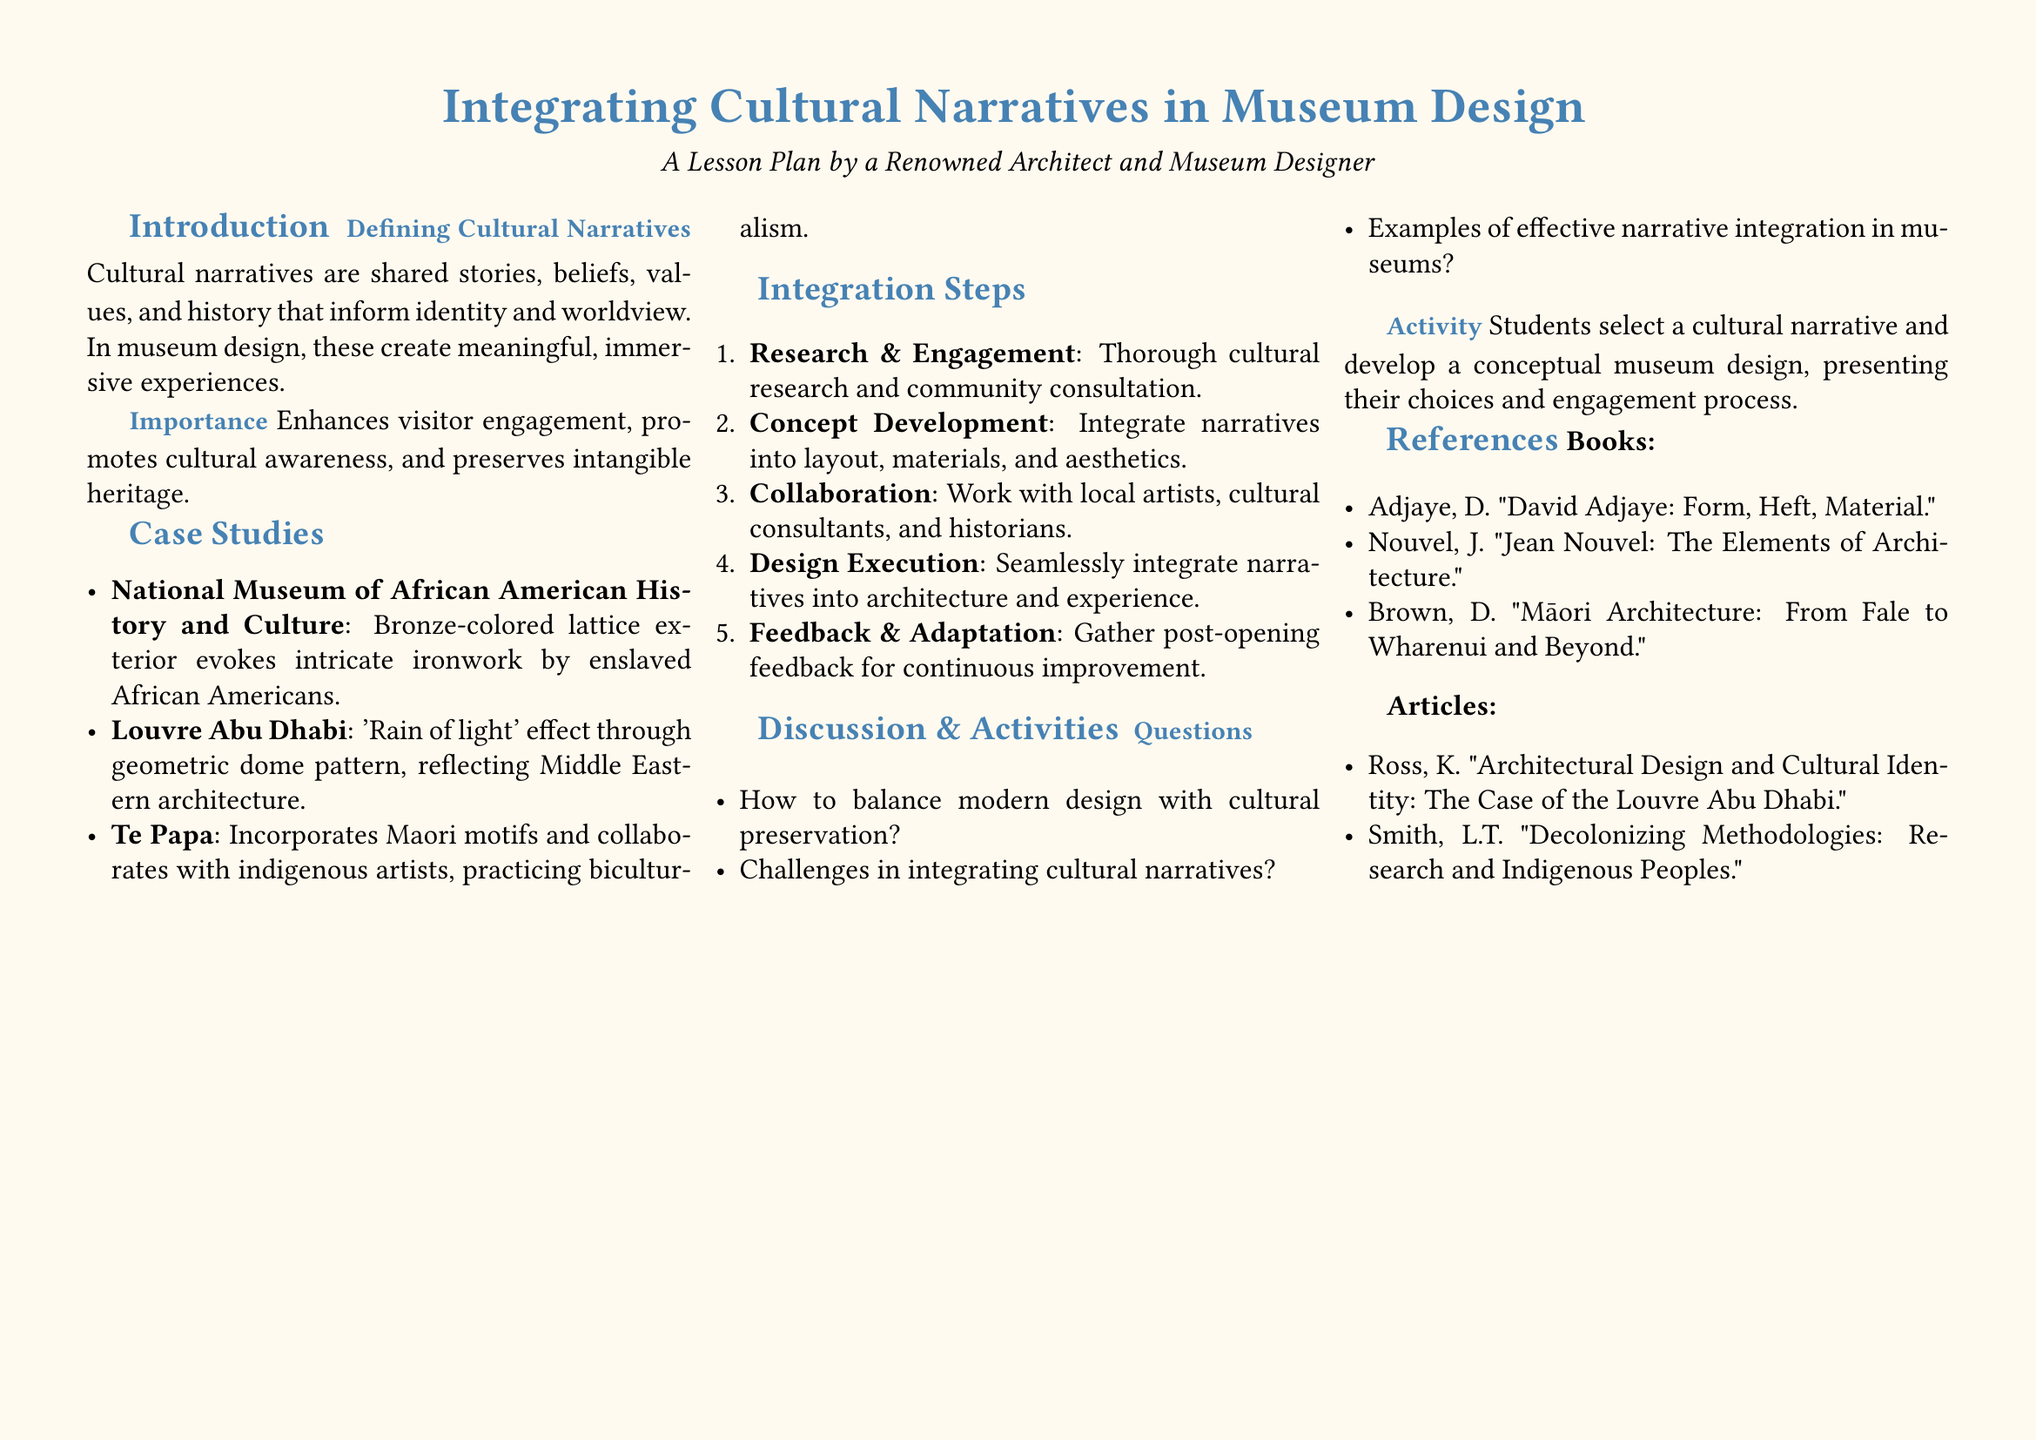What are cultural narratives? Cultural narratives are shared stories, beliefs, values, and history that inform identity and worldview.
Answer: Shared stories What is the first step in integrating cultural narratives? The first step involves thorough cultural research and community consultation.
Answer: Research & Engagement Which museum incorporates Maori motifs? The museum that incorporates Maori motifs is Te Papa.
Answer: Te Papa What effect is created by the Louvre Abu Dhabi's dome? The effect created by the Louvre Abu Dhabi's dome is 'Rain of light'.
Answer: 'Rain of light' What type of activity do students engage in? Students select a cultural narrative and develop a conceptual museum design.
Answer: Conceptual museum design What is the significance of integrating cultural narratives in museum design? Integrating cultural narratives enhances visitor engagement, promotes cultural awareness, and preserves intangible heritage.
Answer: Enhances visitor engagement What book is authored by D. Adjaye? The book authored by D. Adjaye is "David Adjaye: Form, Heft, Material."
Answer: David Adjaye: Form, Heft, Material What challenge is mentioned in the discussion section? One of the challenges mentioned is the balance between modern design and cultural preservation.
Answer: Balance modern design with cultural preservation 